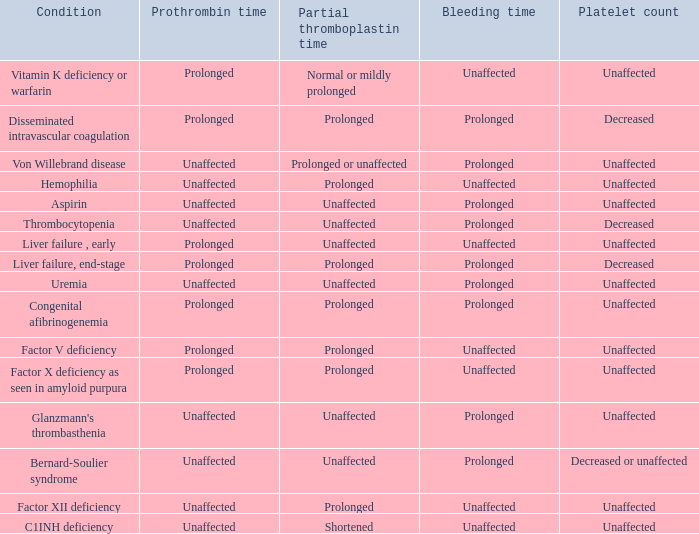What disorder exhibits a normal partial thromboplastin time, platelet count, and prothrombin time? Aspirin, Uremia, Glanzmann's thrombasthenia. 